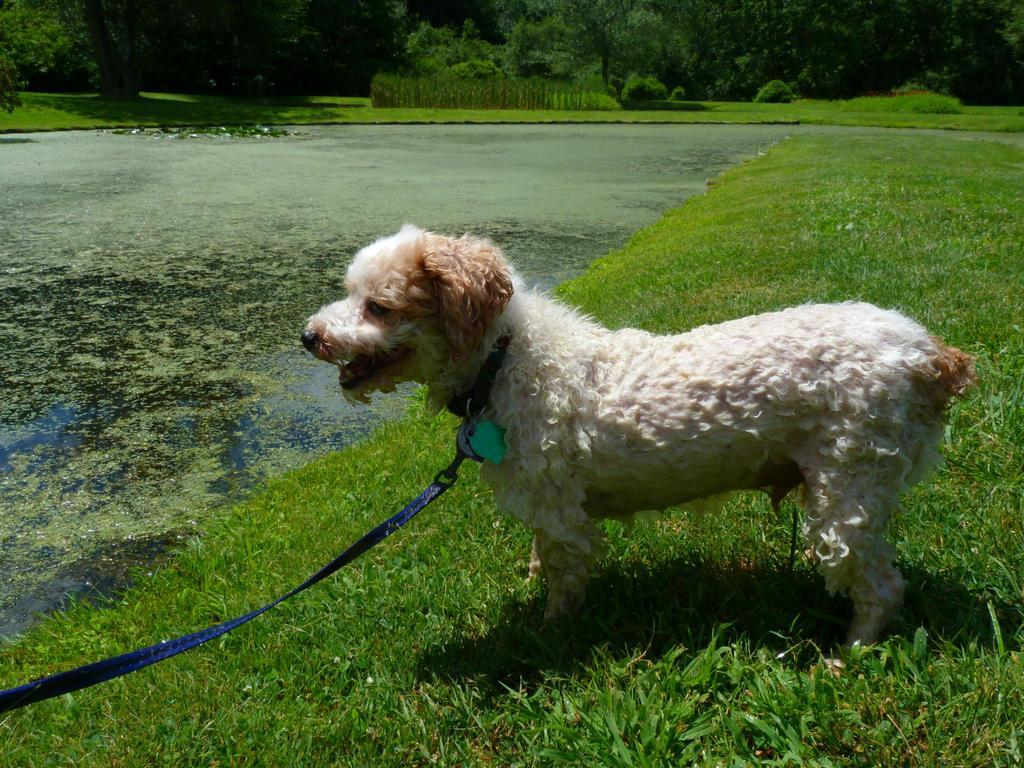What is one of the natural elements present in the image? There is water in the image. What type of vegetation can be seen in the image? There is grass in the image. What is the color of the belt visible in the image? There is a blue color belt in the image. What type of animal is standing in the image? There is a white-colored dog standing in the image. What can be observed as a result of the light source in the image? Shadows are visible in the image. What can be seen in the distance in the image? There are trees in the background of the image. What type of seed is being planted by the worm in the image? There is no seed or worm present in the image. 